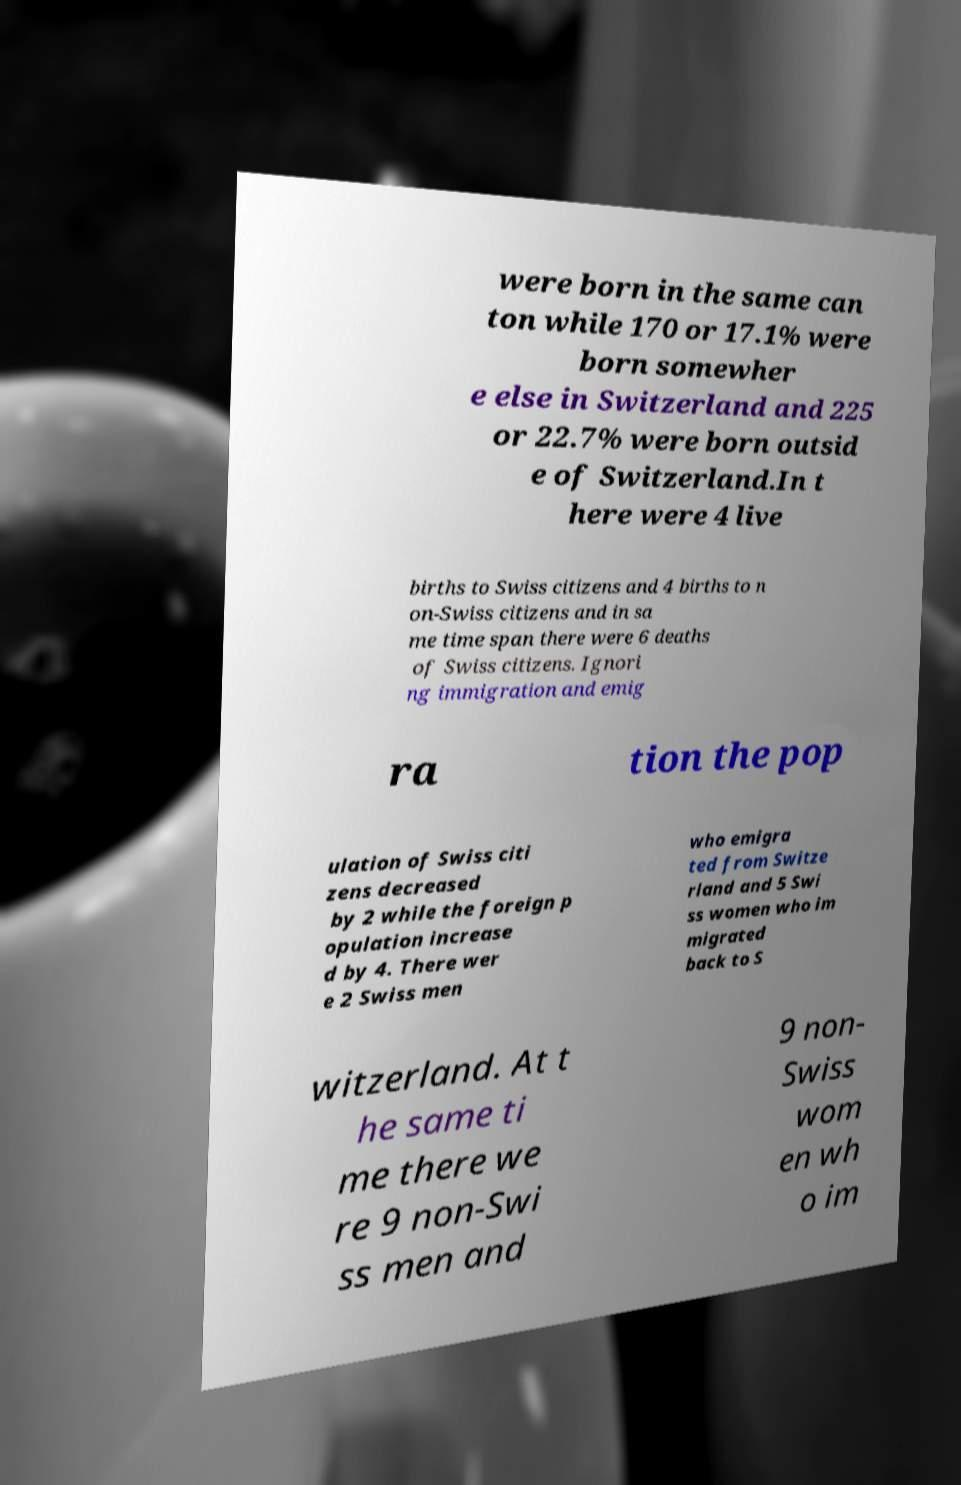There's text embedded in this image that I need extracted. Can you transcribe it verbatim? were born in the same can ton while 170 or 17.1% were born somewher e else in Switzerland and 225 or 22.7% were born outsid e of Switzerland.In t here were 4 live births to Swiss citizens and 4 births to n on-Swiss citizens and in sa me time span there were 6 deaths of Swiss citizens. Ignori ng immigration and emig ra tion the pop ulation of Swiss citi zens decreased by 2 while the foreign p opulation increase d by 4. There wer e 2 Swiss men who emigra ted from Switze rland and 5 Swi ss women who im migrated back to S witzerland. At t he same ti me there we re 9 non-Swi ss men and 9 non- Swiss wom en wh o im 